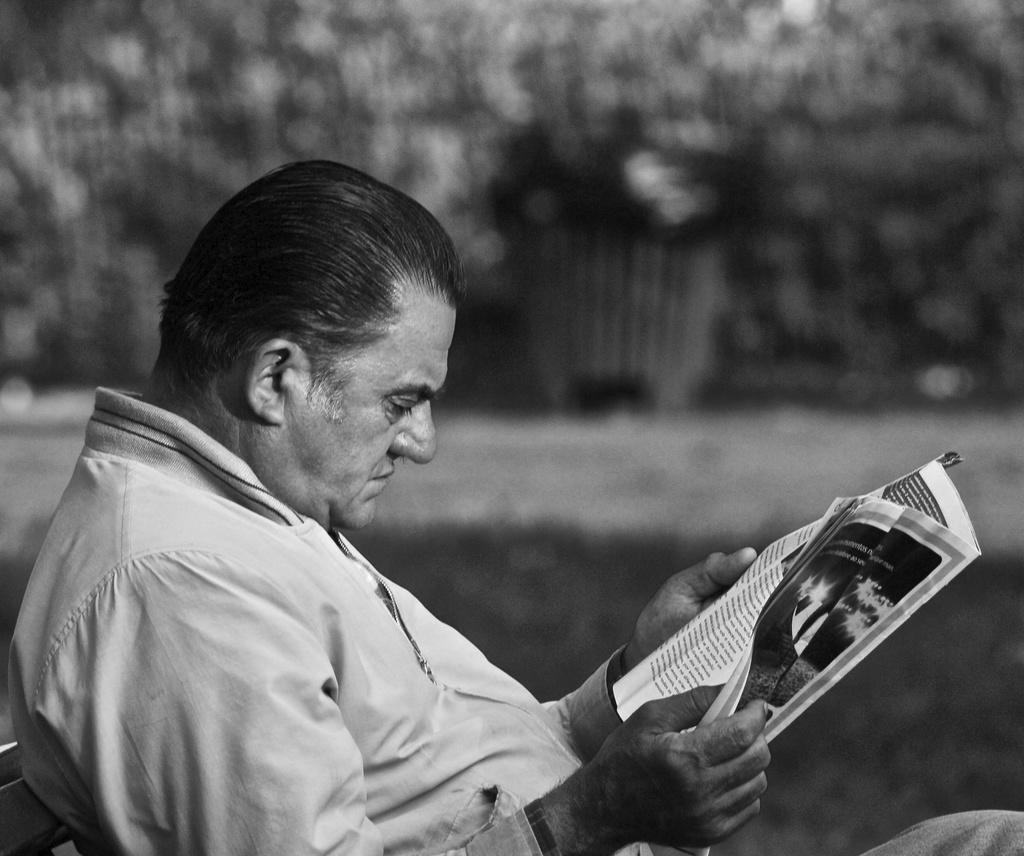Describe this image in one or two sentences. In the image we can see the black and white picture of a man sitting, wearing clothes and holding the paper in the hands and the background is blurred. 